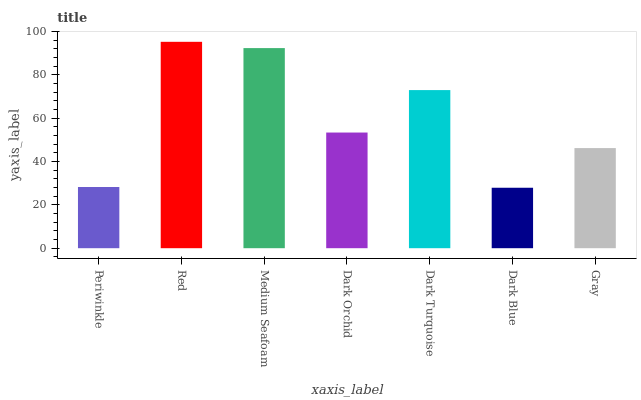Is Dark Blue the minimum?
Answer yes or no. Yes. Is Red the maximum?
Answer yes or no. Yes. Is Medium Seafoam the minimum?
Answer yes or no. No. Is Medium Seafoam the maximum?
Answer yes or no. No. Is Red greater than Medium Seafoam?
Answer yes or no. Yes. Is Medium Seafoam less than Red?
Answer yes or no. Yes. Is Medium Seafoam greater than Red?
Answer yes or no. No. Is Red less than Medium Seafoam?
Answer yes or no. No. Is Dark Orchid the high median?
Answer yes or no. Yes. Is Dark Orchid the low median?
Answer yes or no. Yes. Is Medium Seafoam the high median?
Answer yes or no. No. Is Dark Turquoise the low median?
Answer yes or no. No. 